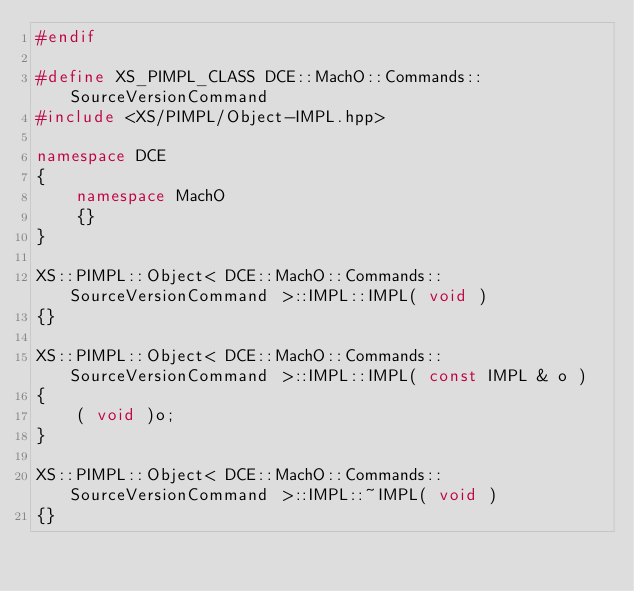Convert code to text. <code><loc_0><loc_0><loc_500><loc_500><_C++_>#endif

#define XS_PIMPL_CLASS DCE::MachO::Commands::SourceVersionCommand
#include <XS/PIMPL/Object-IMPL.hpp>

namespace DCE
{
    namespace MachO
    {}
}

XS::PIMPL::Object< DCE::MachO::Commands::SourceVersionCommand >::IMPL::IMPL( void )
{}

XS::PIMPL::Object< DCE::MachO::Commands::SourceVersionCommand >::IMPL::IMPL( const IMPL & o )
{
    ( void )o;
}

XS::PIMPL::Object< DCE::MachO::Commands::SourceVersionCommand >::IMPL::~IMPL( void )
{}
</code> 